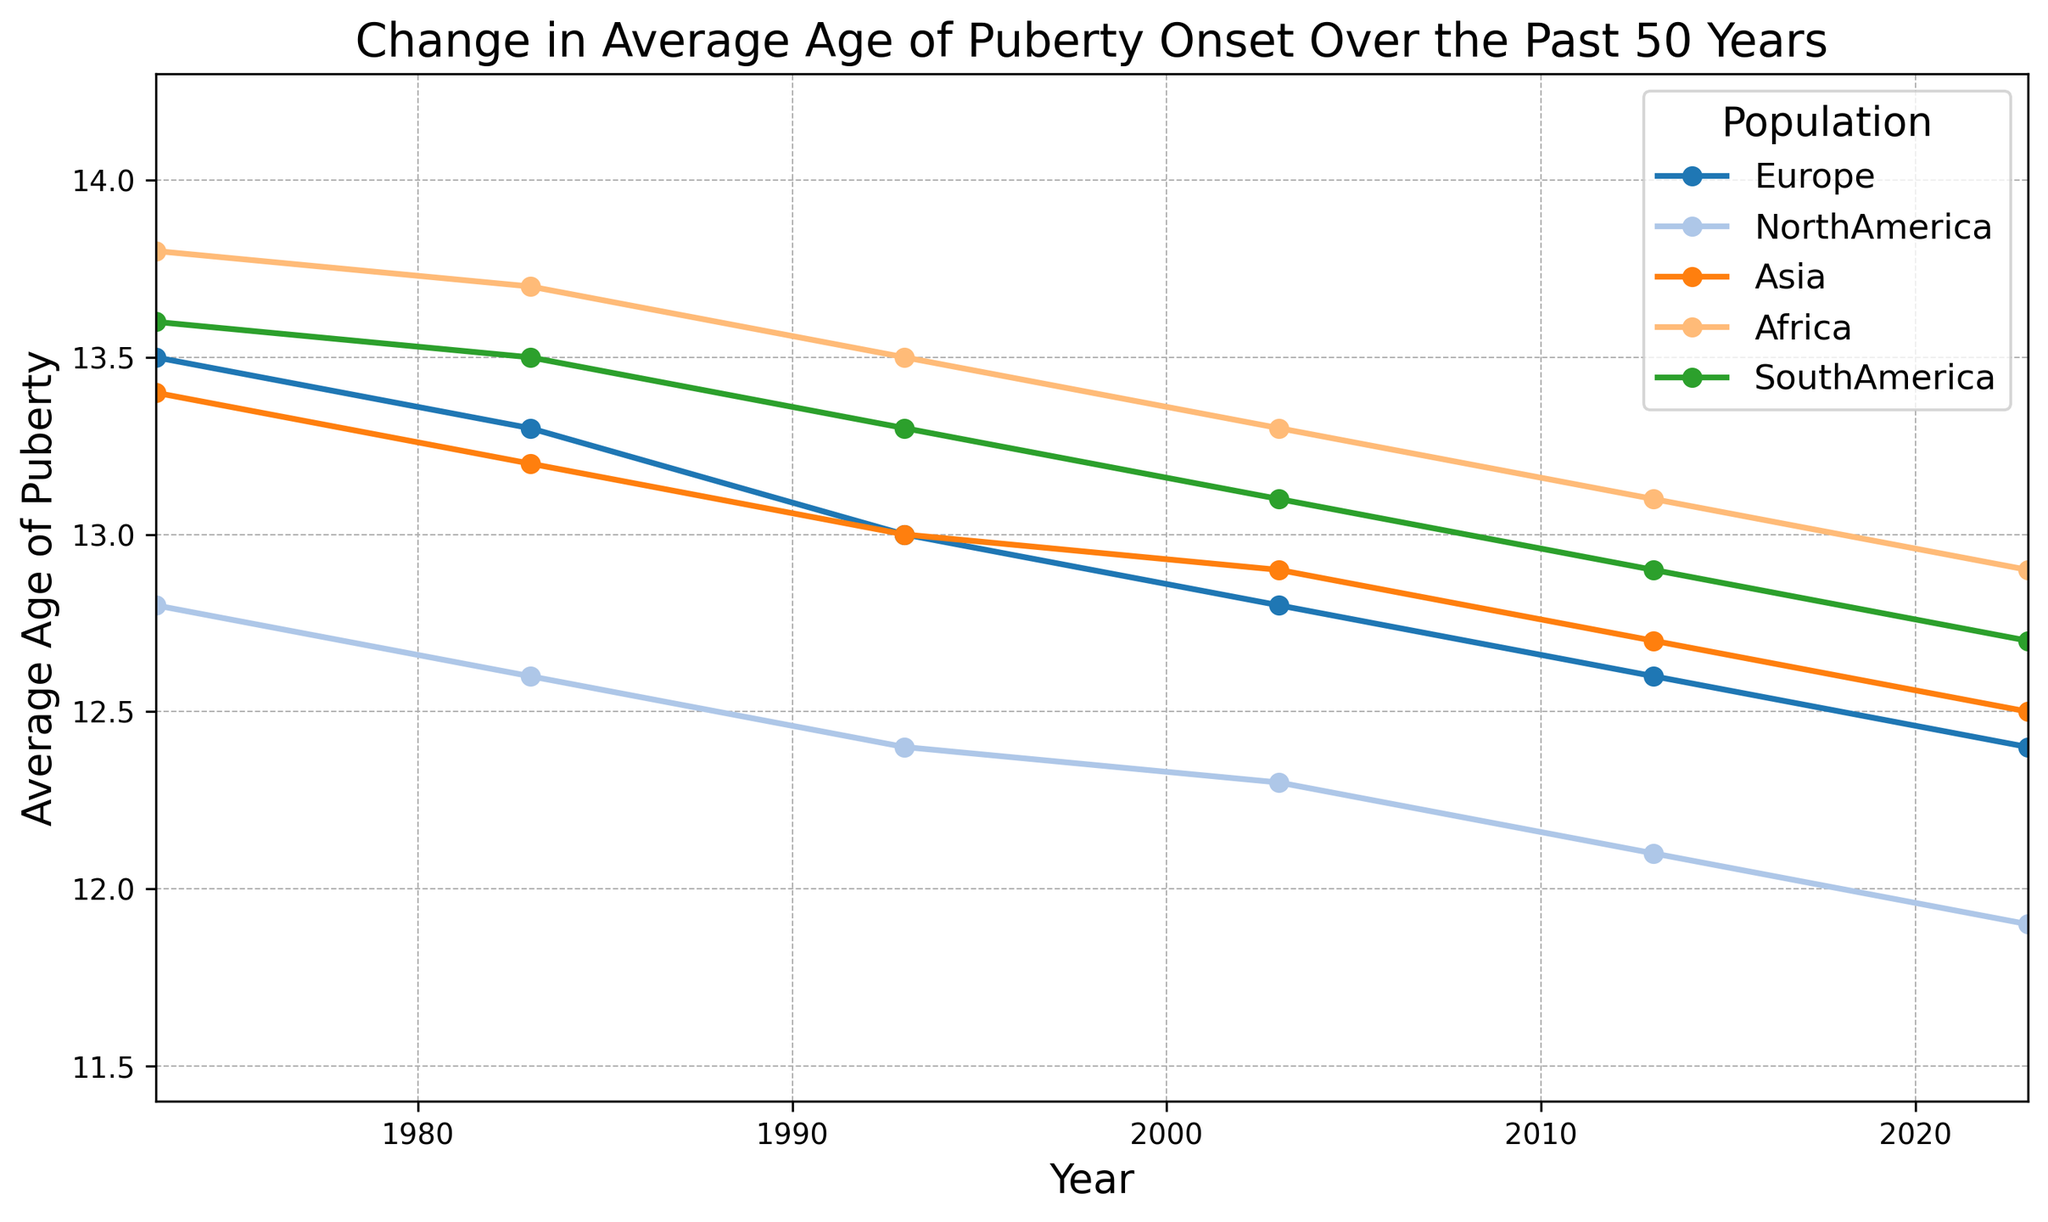What was the average age of puberty onset in Europe in 2023? The figure shows the average age of puberty onset for Europe in different years. Locate the point corresponding to 2023 on the x-axis and find its corresponding y-value.
Answer: 12.4 How much has the average age of puberty onset decreased in North America from 1973 to 2023? Find the average age of puberty onset in North America in 1973 and 2023 from the figure, then subtract the value in 2023 from the value in 1973. For 1973, it is 12.8, and for 2023, it is 11.9. So, the decrease is 12.8 - 11.9 = 0.9 years.
Answer: 0.9 Which population showed the greatest decrease in the average age of puberty onset over the past 50 years? Compare the decrease in average age of puberty onset for each population between 1973 and 2023. The largest decrease can be identified visually by looking for the steepest overall decline in the plotted lines.
Answer: North America In which year did Asia experience the average age of puberty onset decrease to 12.9? Trace the line for Asia and see where it crosses the y-axis value of 12.9. Check the corresponding year on the x-axis.
Answer: 2003 How much lower was the average age of puberty onset in Africa in 1993 compared to Europe in 1993? Note the average age of puberty onset in Africa and Europe in 1993 from the graph. For Africa, it is 13.5, and for Europe, it is 13.0. Subtract the value for Europe from the value for Africa: 13.5 - 13.0 = 0.5 years.
Answer: 0.5 What was the range of average ages of puberty onset in South America from 1973 to 2023? Identify the highest and lowest y-values for South America in the given period. The highest value is 13.6 in 1973, and the lowest value is 12.7 in 2023, so the range is 13.6 - 12.7 = 0.9 years.
Answer: 0.9 In 2023, which population had the highest average age of puberty onset? Locate the points corresponding to 2023 on the x-axis for all populations. The population with the highest y-value (average age) at 2023 represents the answer.
Answer: Africa How does the trend in average age of puberty onset in Europe compare to that in Asia over the past 50 years? Examine the slopes of the lines representing Europe and Asia. Both show a downward trend, but Europe’s line is steeper, indicating a faster decline compared to Asia.
Answer: Europe declined faster What is the average decrease per decade in the average age of puberty onset for South America from 1973 to 2023? Calculate the total decrease in South America from 1973 (13.6) to 2023 (12.7) which is 0.9 years, and then divide by the number of decades (5). So, 0.9 / 5 = 0.18 years per decade.
Answer: 0.18 Among the populations shown, which one had the smallest change in average age of puberty onset from 1973 to 2023? Compare the change in average age of puberty onset for each population between 1973 and 2023.
The smallest change occurs in Africa where the change is 13.8 - 12.9 = 0.9 years.
Answer: Africa 